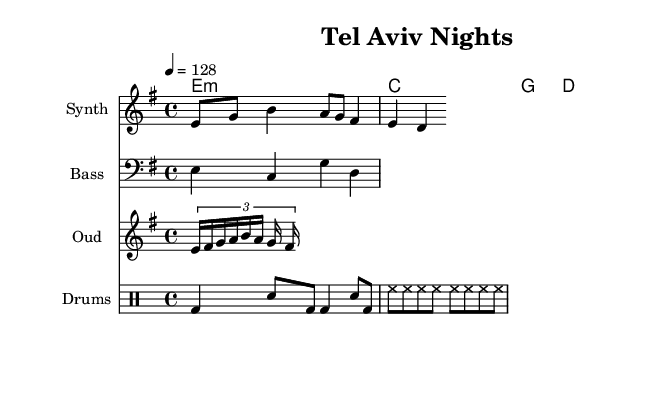What is the key signature of this music? The key signature indicates that this piece is in E minor, which has one sharp (F#). This is evident from the global settings in the code that specify the key as E minor.
Answer: E minor What is the time signature of this music? The time signature is defined as 4/4, which is common in dance music. This means there are four beats per measure, as noted in the global settings section.
Answer: 4/4 What is the tempo marking? The tempo marking indicates the speed of the music, and it is set at 128 beats per minute (BPM). This is found in the global settings where the tempo is specified.
Answer: 128 How many measures are in the synth melody? The synth melody consists of four measures, which can be counted based on the note groupings and the time signature of 4/4. Each measure in the melody section contributes to this total.
Answer: 4 What instruments are used in this piece? The piece includes four distinct instruments: Synth, Bass, Oud, and Drums. This is indicated by the separate staves for each instrument in the score.
Answer: Synth, Bass, Oud, Drums What note values are present in the drum pattern? The drum pattern contains quarter notes and eighth notes. This can be determined by looking at the different note symbols used, specifically bd4 which represents a quarter note and sn8 for an eighth note.
Answer: Quarter notes and eighth notes How is the oud riff structured? The oud riff is structured with a tuplet, specifically a triplet of sixteenth notes, followed by regular eighth notes. The tuplet is introduced in the score by the notation before the notes.
Answer: Triplet 